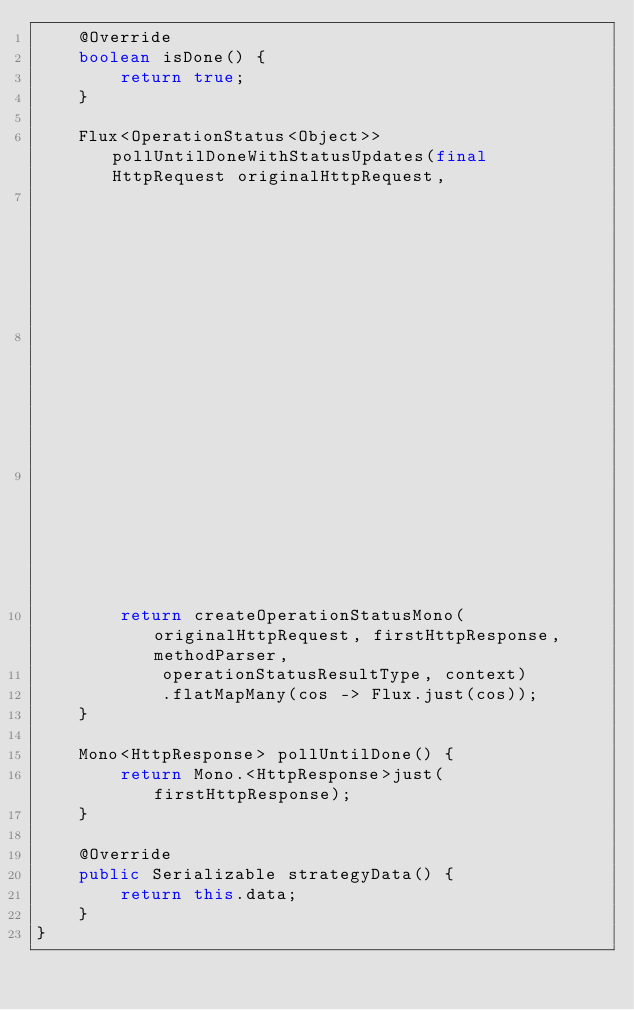Convert code to text. <code><loc_0><loc_0><loc_500><loc_500><_Java_>    @Override
    boolean isDone() {
        return true;
    }

    Flux<OperationStatus<Object>> pollUntilDoneWithStatusUpdates(final HttpRequest originalHttpRequest,
                                                                 final SwaggerMethodParser methodParser,
                                                                 final Type operationStatusResultType,
                                                                 Context context) {
        return createOperationStatusMono(originalHttpRequest, firstHttpResponse, methodParser,
            operationStatusResultType, context)
            .flatMapMany(cos -> Flux.just(cos));
    }

    Mono<HttpResponse> pollUntilDone() {
        return Mono.<HttpResponse>just(firstHttpResponse);
    }

    @Override
    public Serializable strategyData() {
        return this.data;
    }
}
</code> 